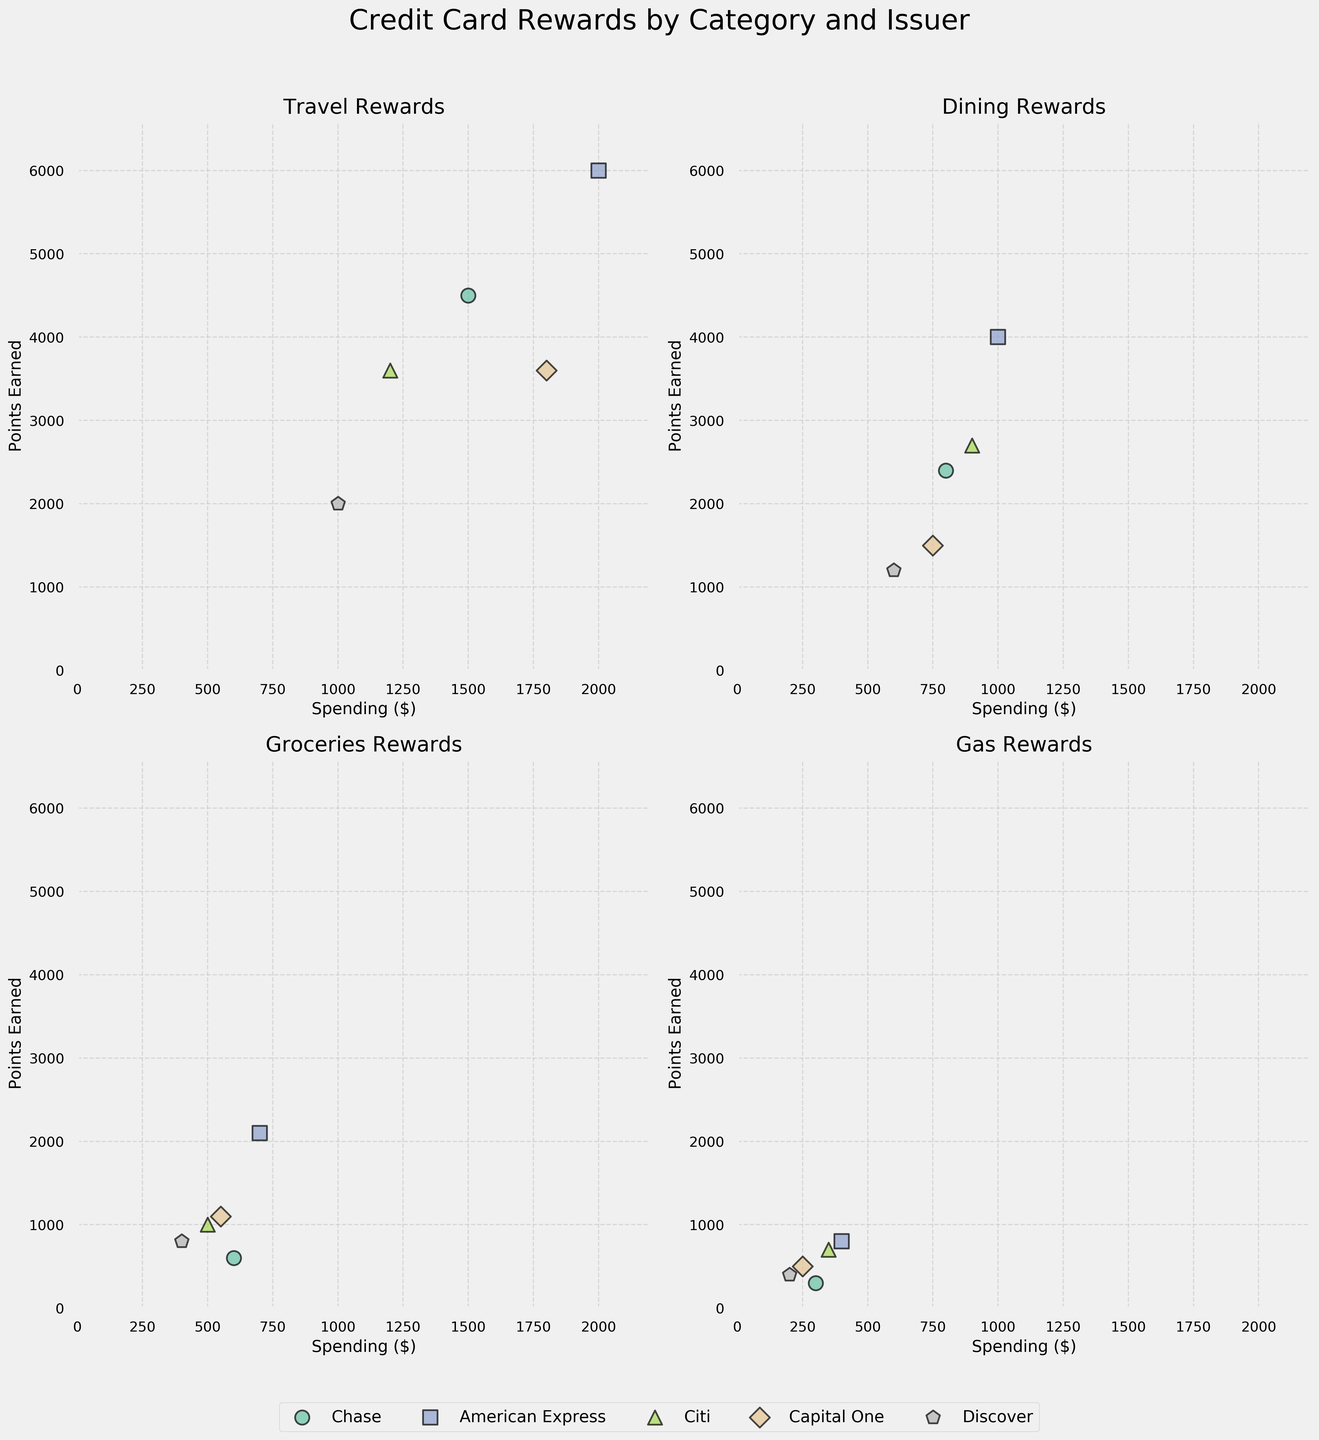What is the title of the plot? The title of the plot is displayed above the subplots.
Answer: Credit Card Rewards by Category and Issuer How many different card issuers are represented in the plot? By counting the unique legends or different markers/colors within the plot, we can determine there are five card issuers.
Answer: 5 Which spending category shows the highest number of points earned for American Express? By looking at the points earned for each category in the American Express subplot, Travel has the highest value.
Answer: Travel Which card issuer provides the most points for Dining with $800 spending? By comparing the points earned for dining under $800 spending, Chase provides 2400 points, which is the highest.
Answer: Chase What is the relationship between spending and points earned for Gas across all issuers? Observing the subplot for Gas, the relationship shows a positive correlation—the more you spend, the more points you earn.
Answer: Positive correlation Which card issuer seems to offer the least rewards across categories? By comparing the points earned across categories for each issuer, Discover often has the lowest points.
Answer: Discover For which category does Citi offer relatively fewer points compared to its spending amount? By comparing the points earned to spending in each category for Citi, Groceries tends to have a lower ratio (500 spending gives 1000 points).
Answer: Groceries What's the total number of points earned across all spending categories for Capital One? Travel: 3600, Dining: 1500, Groceries: 1100, Gas: 500. Sum: 3600 + 1500 + 1100 + 500 = 6700.
Answer: 6700 Which category has the highest variation in points earned across different card issuers? By comparing the range of points earned for each spending category, Travel shows the largest variation.
Answer: Travel 